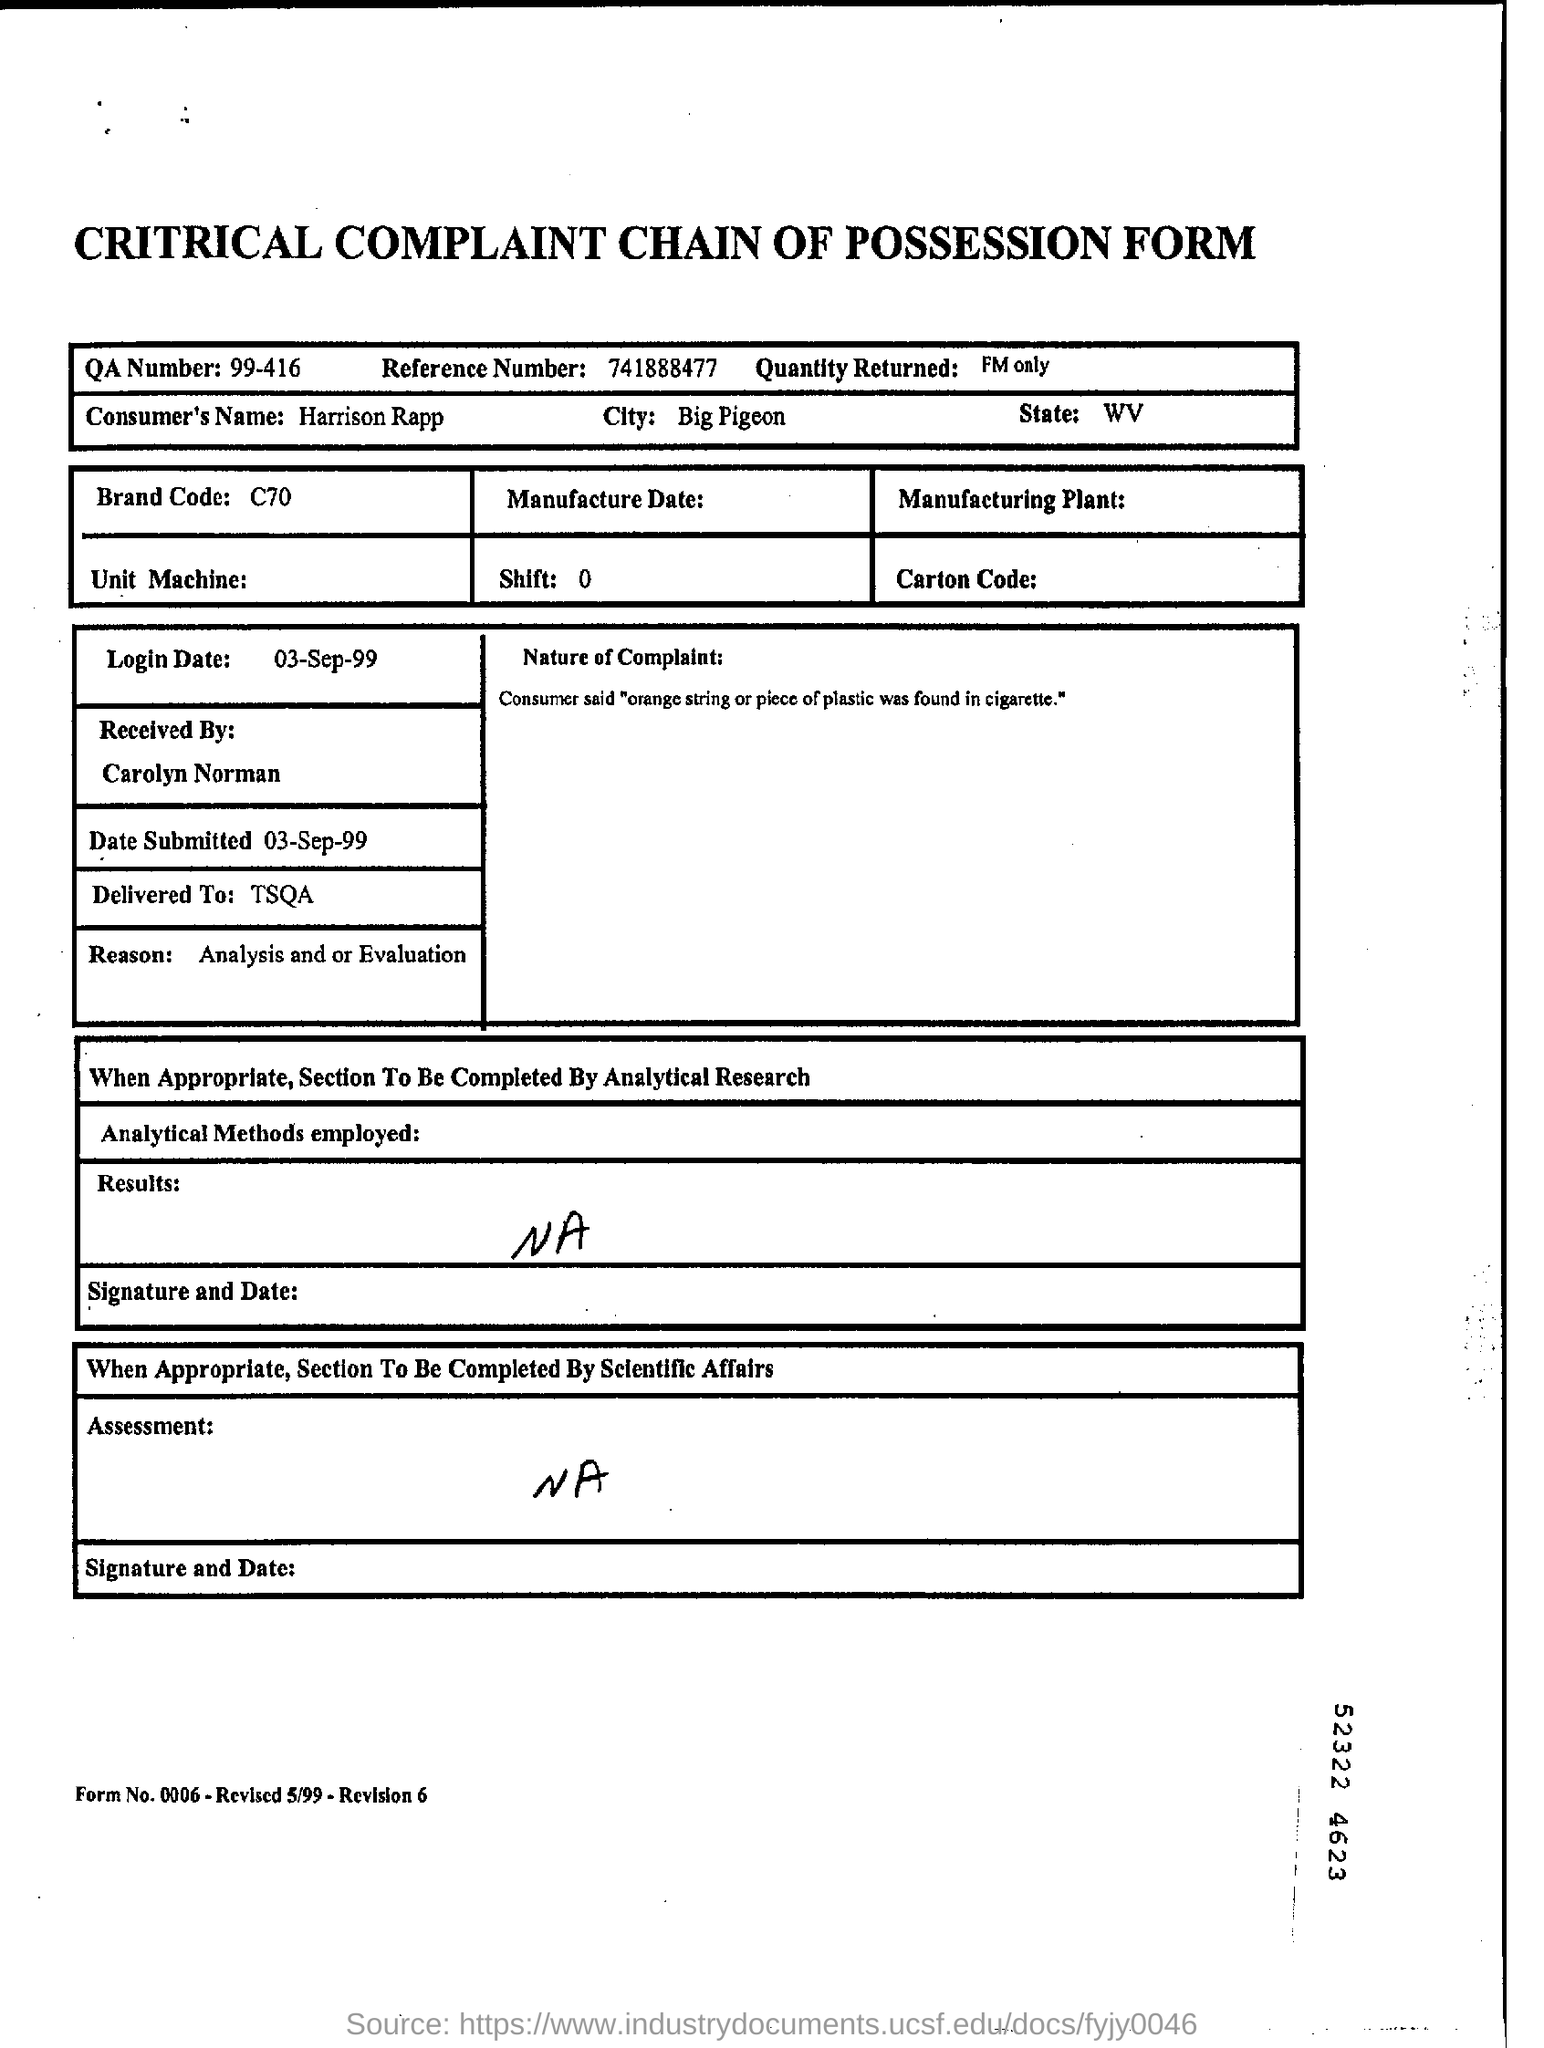Mention a couple of crucial points in this snapshot. The consumer's city is Big Pigeon. The recipient of the delivery was TSQA. The reference number provided is 741888477. The QA number is 99-416. The brand code is C70... 